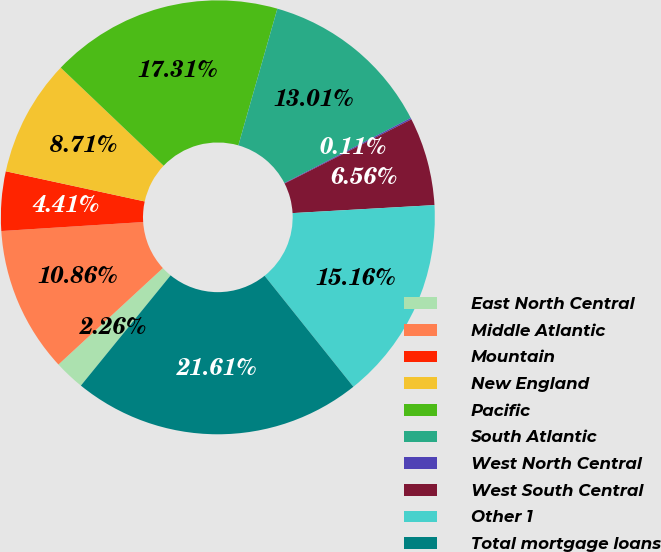Convert chart to OTSL. <chart><loc_0><loc_0><loc_500><loc_500><pie_chart><fcel>East North Central<fcel>Middle Atlantic<fcel>Mountain<fcel>New England<fcel>Pacific<fcel>South Atlantic<fcel>West North Central<fcel>West South Central<fcel>Other 1<fcel>Total mortgage loans<nl><fcel>2.26%<fcel>10.86%<fcel>4.41%<fcel>8.71%<fcel>17.31%<fcel>13.01%<fcel>0.11%<fcel>6.56%<fcel>15.16%<fcel>21.61%<nl></chart> 